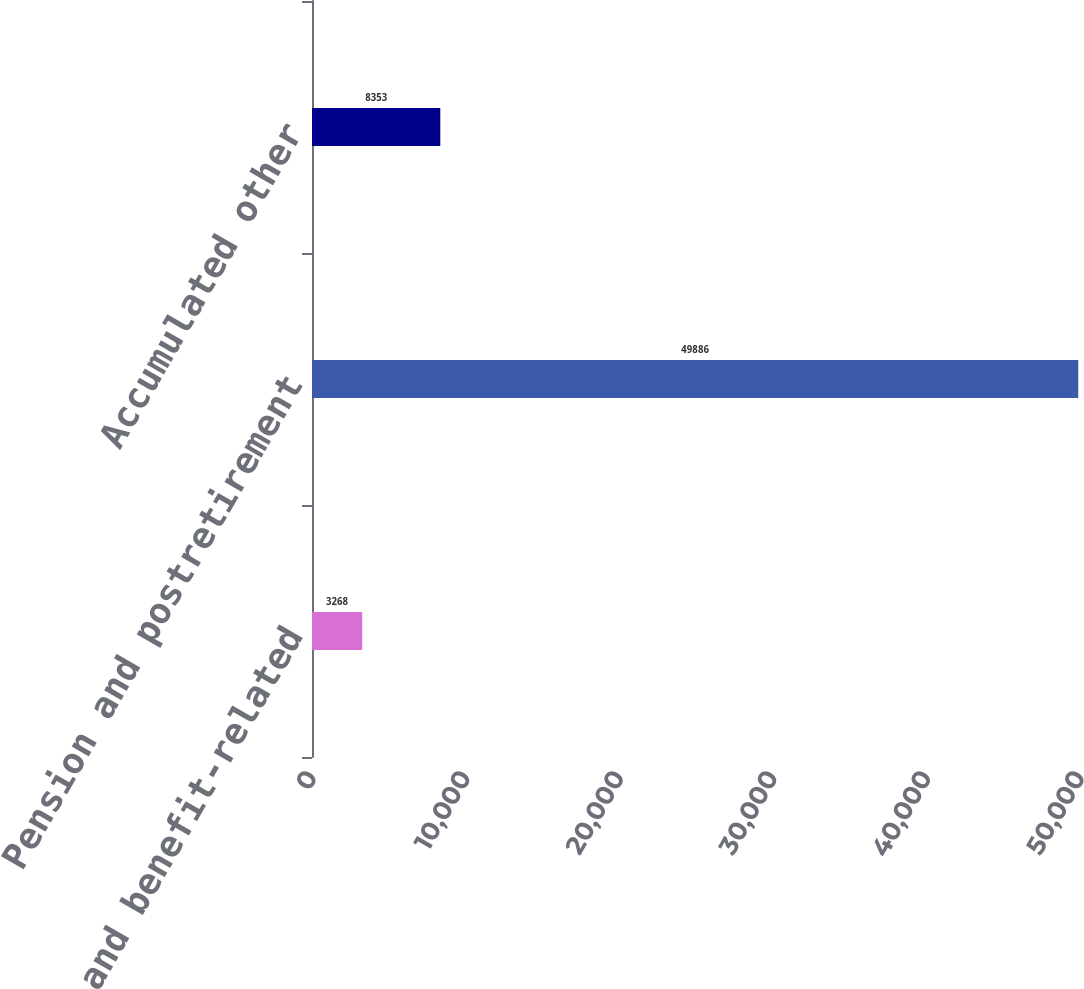Convert chart to OTSL. <chart><loc_0><loc_0><loc_500><loc_500><bar_chart><fcel>Payroll and benefit-related<fcel>Pension and postretirement<fcel>Accumulated other<nl><fcel>3268<fcel>49886<fcel>8353<nl></chart> 